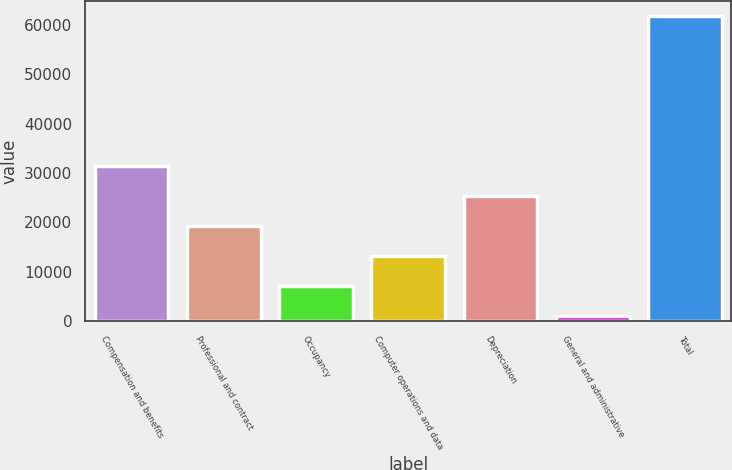Convert chart. <chart><loc_0><loc_0><loc_500><loc_500><bar_chart><fcel>Compensation and benefits<fcel>Professional and contract<fcel>Occupancy<fcel>Computer operations and data<fcel>Depreciation<fcel>General and administrative<fcel>Total<nl><fcel>31469<fcel>19318.2<fcel>7167.4<fcel>13242.8<fcel>25393.6<fcel>1092<fcel>61846<nl></chart> 